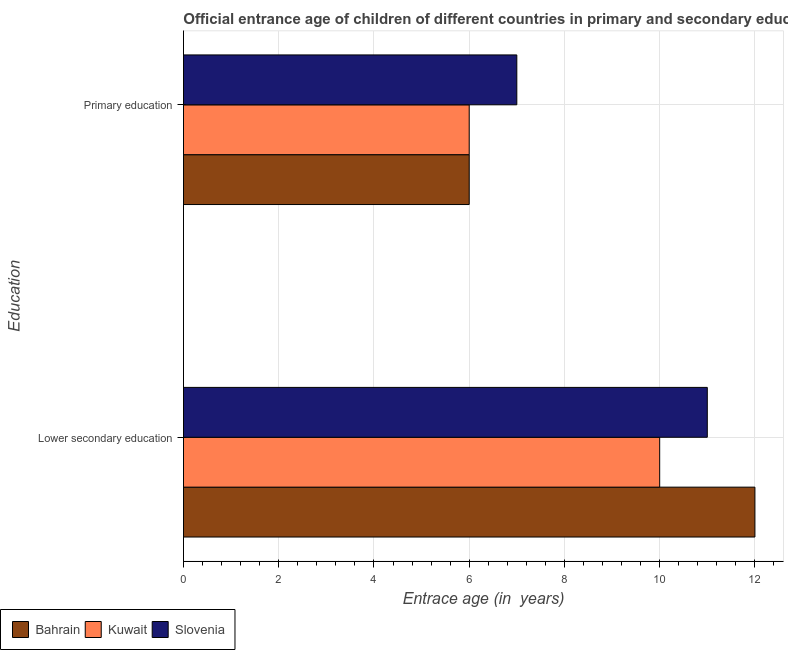How many groups of bars are there?
Your answer should be very brief. 2. Are the number of bars per tick equal to the number of legend labels?
Provide a succinct answer. Yes. Are the number of bars on each tick of the Y-axis equal?
Make the answer very short. Yes. How many bars are there on the 2nd tick from the bottom?
Keep it short and to the point. 3. What is the label of the 1st group of bars from the top?
Make the answer very short. Primary education. What is the entrance age of children in lower secondary education in Bahrain?
Your answer should be very brief. 12. Across all countries, what is the maximum entrance age of children in lower secondary education?
Keep it short and to the point. 12. Across all countries, what is the minimum entrance age of children in lower secondary education?
Offer a terse response. 10. In which country was the entrance age of children in lower secondary education maximum?
Give a very brief answer. Bahrain. In which country was the entrance age of chiildren in primary education minimum?
Offer a very short reply. Bahrain. What is the total entrance age of chiildren in primary education in the graph?
Give a very brief answer. 19. What is the difference between the entrance age of children in lower secondary education in Bahrain and the entrance age of chiildren in primary education in Kuwait?
Ensure brevity in your answer.  6. What is the average entrance age of children in lower secondary education per country?
Offer a terse response. 11. What is the difference between the entrance age of chiildren in primary education and entrance age of children in lower secondary education in Kuwait?
Keep it short and to the point. -4. Is the entrance age of children in lower secondary education in Kuwait less than that in Bahrain?
Provide a succinct answer. Yes. In how many countries, is the entrance age of children in lower secondary education greater than the average entrance age of children in lower secondary education taken over all countries?
Keep it short and to the point. 1. What does the 3rd bar from the top in Lower secondary education represents?
Keep it short and to the point. Bahrain. What does the 3rd bar from the bottom in Lower secondary education represents?
Give a very brief answer. Slovenia. How many bars are there?
Provide a short and direct response. 6. Are all the bars in the graph horizontal?
Provide a succinct answer. Yes. Are the values on the major ticks of X-axis written in scientific E-notation?
Your answer should be compact. No. Does the graph contain grids?
Your answer should be very brief. Yes. How many legend labels are there?
Ensure brevity in your answer.  3. How are the legend labels stacked?
Your answer should be compact. Horizontal. What is the title of the graph?
Keep it short and to the point. Official entrance age of children of different countries in primary and secondary education. Does "Croatia" appear as one of the legend labels in the graph?
Ensure brevity in your answer.  No. What is the label or title of the X-axis?
Offer a very short reply. Entrace age (in  years). What is the label or title of the Y-axis?
Keep it short and to the point. Education. What is the Entrace age (in  years) in Bahrain in Lower secondary education?
Provide a short and direct response. 12. What is the Entrace age (in  years) of Bahrain in Primary education?
Offer a terse response. 6. Across all Education, what is the maximum Entrace age (in  years) of Bahrain?
Your answer should be compact. 12. Across all Education, what is the maximum Entrace age (in  years) in Kuwait?
Your response must be concise. 10. Across all Education, what is the minimum Entrace age (in  years) of Kuwait?
Provide a short and direct response. 6. What is the total Entrace age (in  years) in Bahrain in the graph?
Provide a short and direct response. 18. What is the total Entrace age (in  years) in Slovenia in the graph?
Offer a terse response. 18. What is the difference between the Entrace age (in  years) in Bahrain in Lower secondary education and the Entrace age (in  years) in Slovenia in Primary education?
Provide a succinct answer. 5. What is the difference between the Entrace age (in  years) in Bahrain and Entrace age (in  years) in Slovenia in Lower secondary education?
Your response must be concise. 1. What is the difference between the Entrace age (in  years) of Bahrain and Entrace age (in  years) of Slovenia in Primary education?
Ensure brevity in your answer.  -1. What is the difference between the Entrace age (in  years) in Kuwait and Entrace age (in  years) in Slovenia in Primary education?
Provide a succinct answer. -1. What is the ratio of the Entrace age (in  years) in Bahrain in Lower secondary education to that in Primary education?
Make the answer very short. 2. What is the ratio of the Entrace age (in  years) of Slovenia in Lower secondary education to that in Primary education?
Your answer should be very brief. 1.57. What is the difference between the highest and the second highest Entrace age (in  years) of Bahrain?
Ensure brevity in your answer.  6. What is the difference between the highest and the second highest Entrace age (in  years) in Kuwait?
Your answer should be very brief. 4. What is the difference between the highest and the lowest Entrace age (in  years) of Kuwait?
Keep it short and to the point. 4. What is the difference between the highest and the lowest Entrace age (in  years) of Slovenia?
Give a very brief answer. 4. 